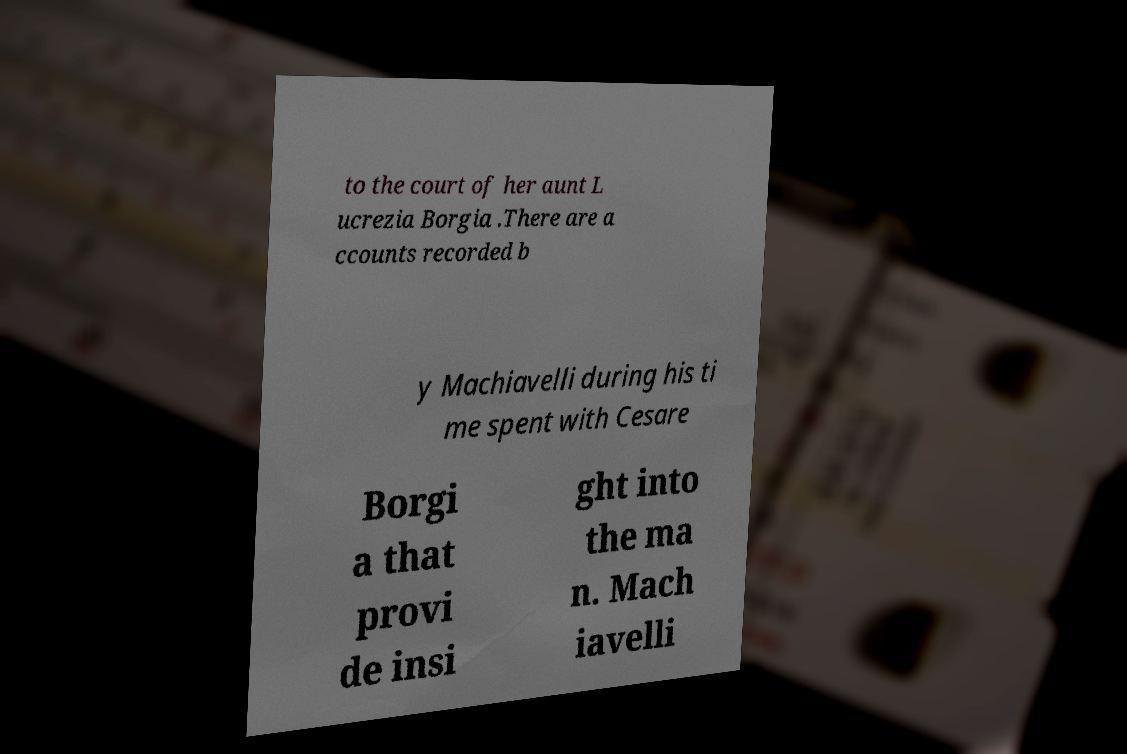Can you read and provide the text displayed in the image?This photo seems to have some interesting text. Can you extract and type it out for me? to the court of her aunt L ucrezia Borgia .There are a ccounts recorded b y Machiavelli during his ti me spent with Cesare Borgi a that provi de insi ght into the ma n. Mach iavelli 